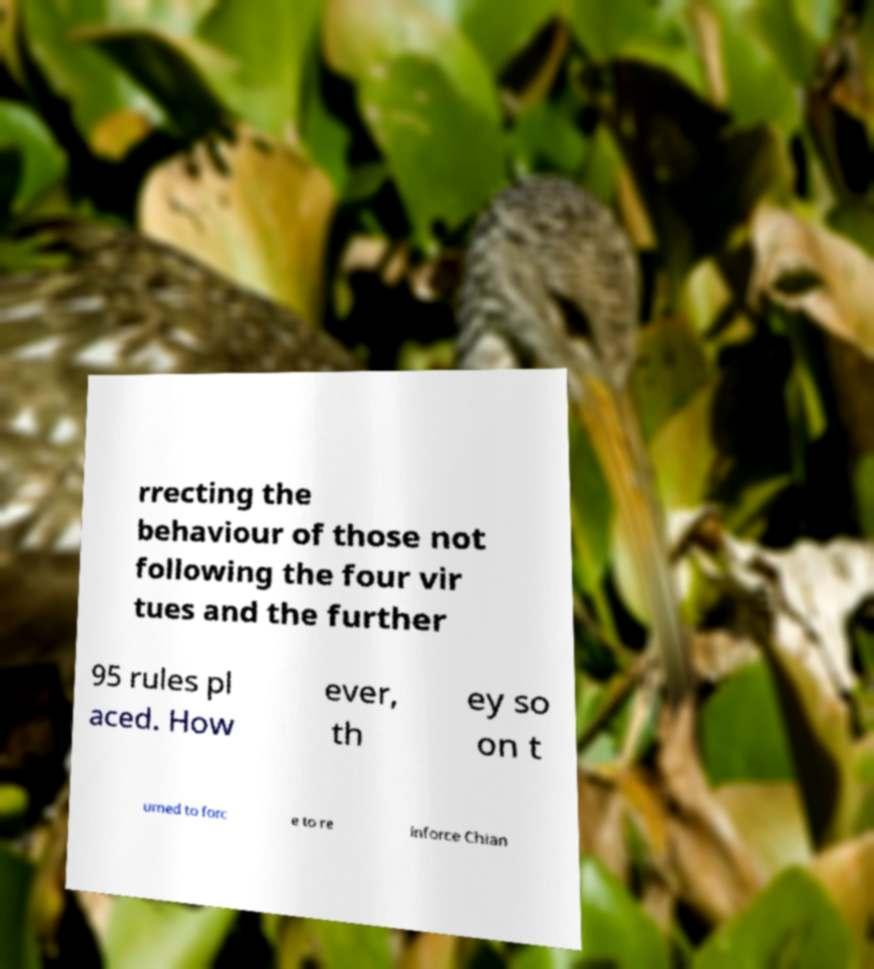Could you assist in decoding the text presented in this image and type it out clearly? rrecting the behaviour of those not following the four vir tues and the further 95 rules pl aced. How ever, th ey so on t urned to forc e to re inforce Chian 